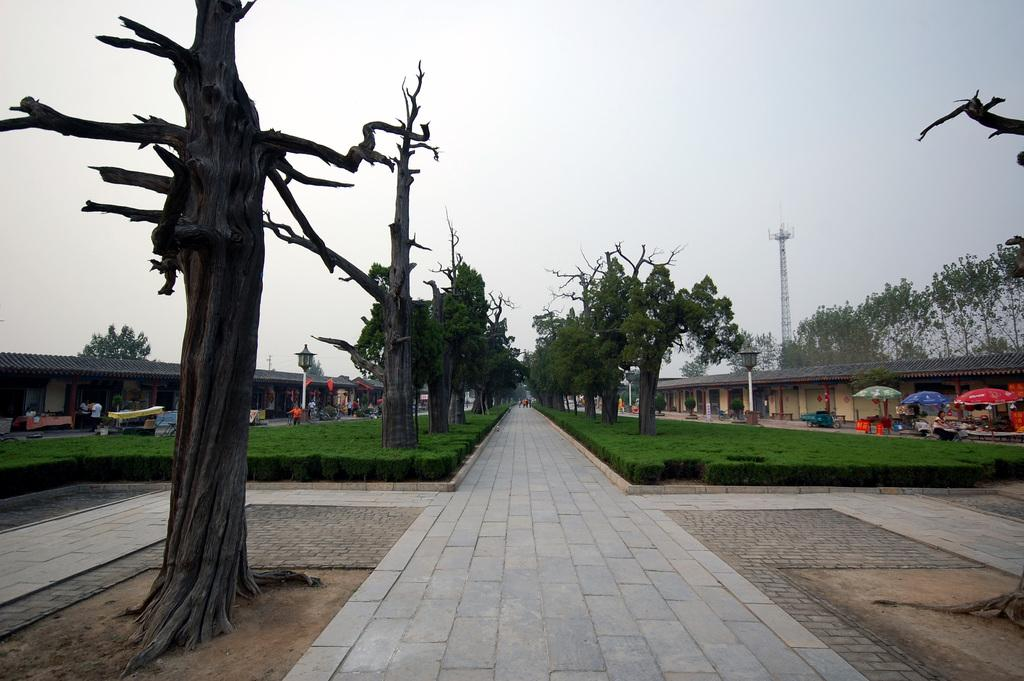What type of surface can be seen in the image? There is a path in the image. What is located in the foreground of the image? Trees are present in the foreground. What objects are visible in the image that might provide shelter or shade? Umbrellas are visible in the image. What type of structures can be seen in the image? Stalls are present in the image. Who is in the image? People are in the image. What is visible in the background of the image? Trees, grassland, a pole, and the sky are visible in the background. What type of blood is visible on the pole in the image? There is no blood visible on the pole in the image. What is the temper of the people in the image? The temper of the people in the image cannot be determined from the image alone. 